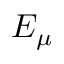<formula> <loc_0><loc_0><loc_500><loc_500>E _ { \mu }</formula> 